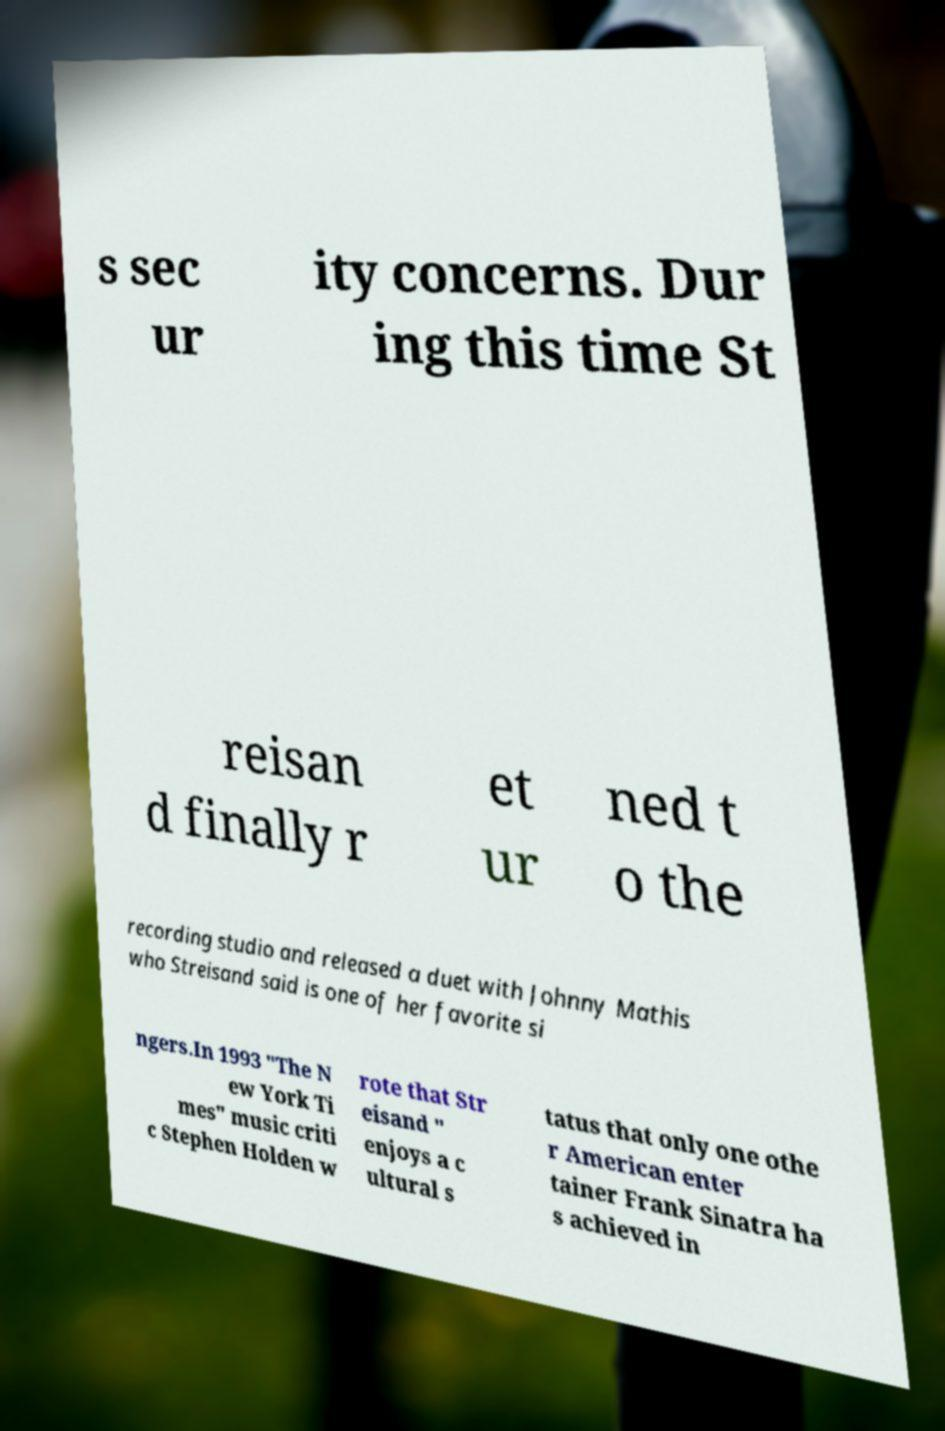Please identify and transcribe the text found in this image. s sec ur ity concerns. Dur ing this time St reisan d finally r et ur ned t o the recording studio and released a duet with Johnny Mathis who Streisand said is one of her favorite si ngers.In 1993 "The N ew York Ti mes" music criti c Stephen Holden w rote that Str eisand " enjoys a c ultural s tatus that only one othe r American enter tainer Frank Sinatra ha s achieved in 